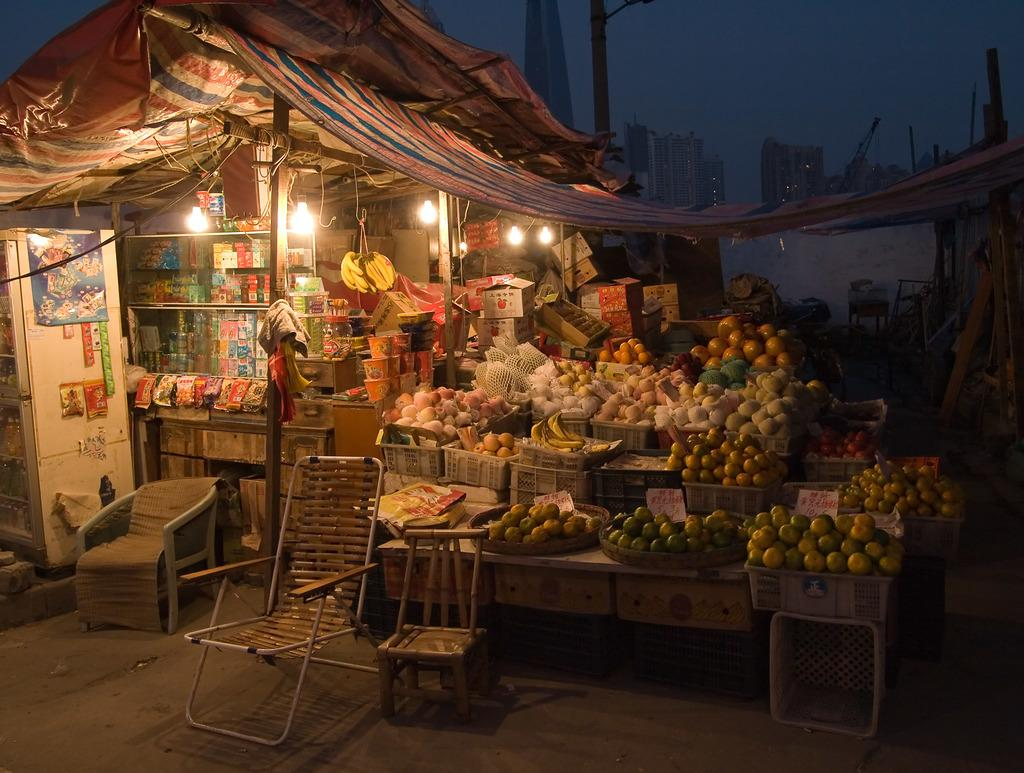What type of furniture is present in the image? There are chairs in the image. What items can be found in the baskets in the image? The baskets contain fruits, including oranges. What can be used for illumination in the image? There are lights in the image. What type of temporary shelter is present in the image? There is a tent in the image. What type of structures can be seen in the image? There are buildings in the image. What is visible in the background of the image? The sky is visible in the background of the image. How much money is being exchanged between the celery stalks in the image? There is no money or celery present in the image. What type of fog can be seen in the image? There is no fog present in the image; the sky is visible in the background. 